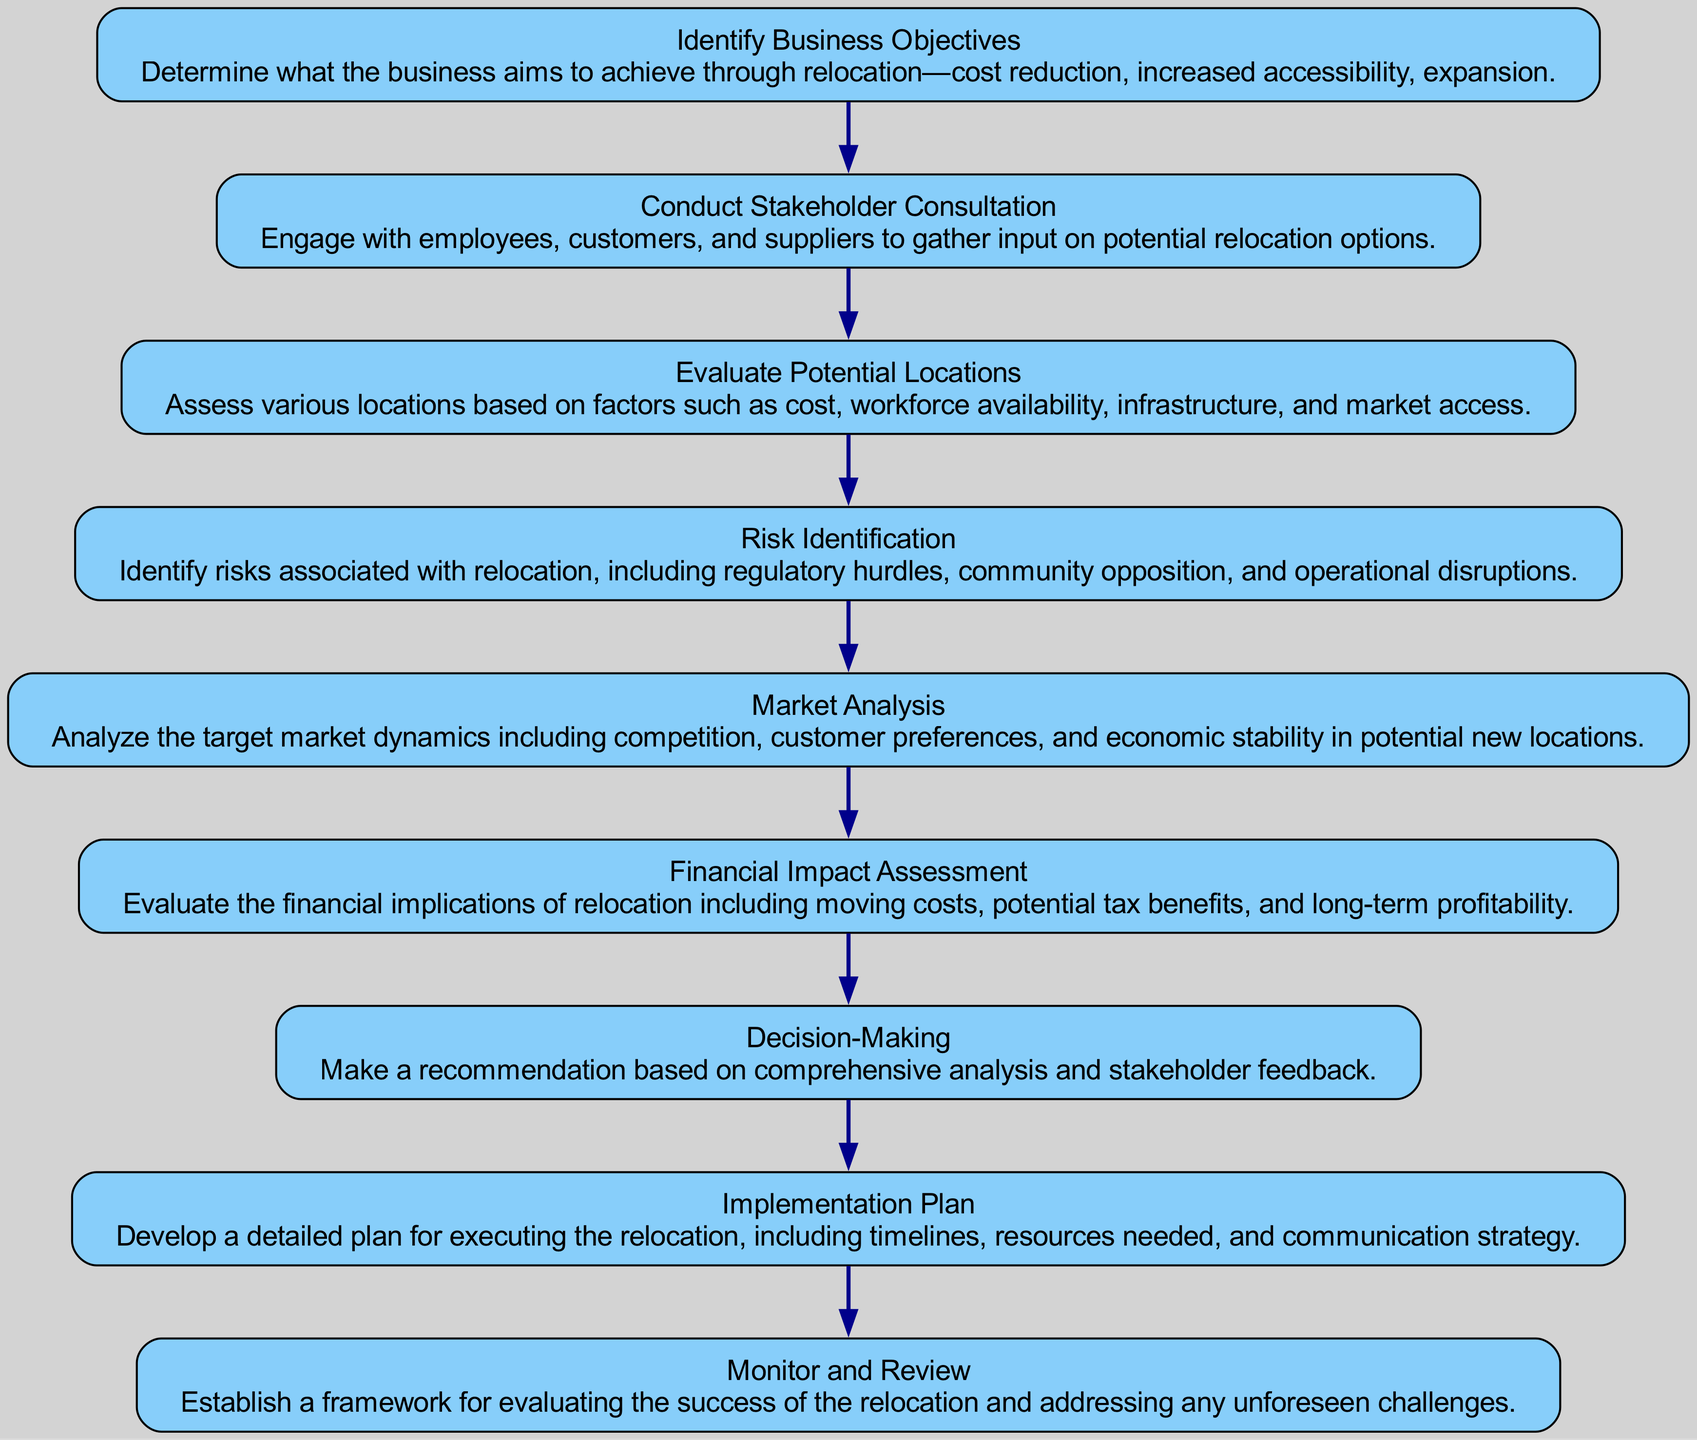What is the first stage in the flow chart? The first stage in the flow chart is labeled "Identify Business Objectives," which highlights the starting point for assessing relocation options.
Answer: Identify Business Objectives How many nodes are in the diagram? By counting the distinct steps laid out in the flow chart, there are a total of nine nodes.
Answer: Nine What follows "Conduct Stakeholder Consultation"? After "Conduct Stakeholder Consultation," the next step in the flow chart is "Evaluate Potential Locations."
Answer: Evaluate Potential Locations Which node assesses the financial implications of relocation? The node that focuses on financial implications is labeled "Financial Impact Assessment," indicating its importance in the analysis process.
Answer: Financial Impact Assessment What is the last step in the flow chart? The last step is "Monitor and Review," which deals with the evaluation after the relocation process is completed to address any ongoing challenges.
Answer: Monitor and Review What processes are analyzed during the "Market Analysis" stage? The "Market Analysis" stage involves analyzing target market dynamics, competition, customer preferences, and economic stability, which are essential for making an informed decision about a relocation.
Answer: Market dynamics, competition, customer preferences, economic stability How are risks identified according to the diagram? Risks are identified in the "Risk Identification" node, where various potential relocation-related risks such as regulatory issues and community resistance are assessed.
Answer: Risk Identification What is the purpose of the "Implementation Plan"? The "Implementation Plan" step is designed to outline how the business will execute the relocation, ensuring that resources and timelines are clearly defined.
Answer: Develop a detailed plan for executing the relocation What is the relationship between "Risk Identification" and "Decision-Making"? "Risk Identification" precedes "Decision-Making," indicating that understanding the associated risks is crucial before making a recommendation based on the comprehensive analysis.
Answer: Risk Identification precedes Decision-Making 